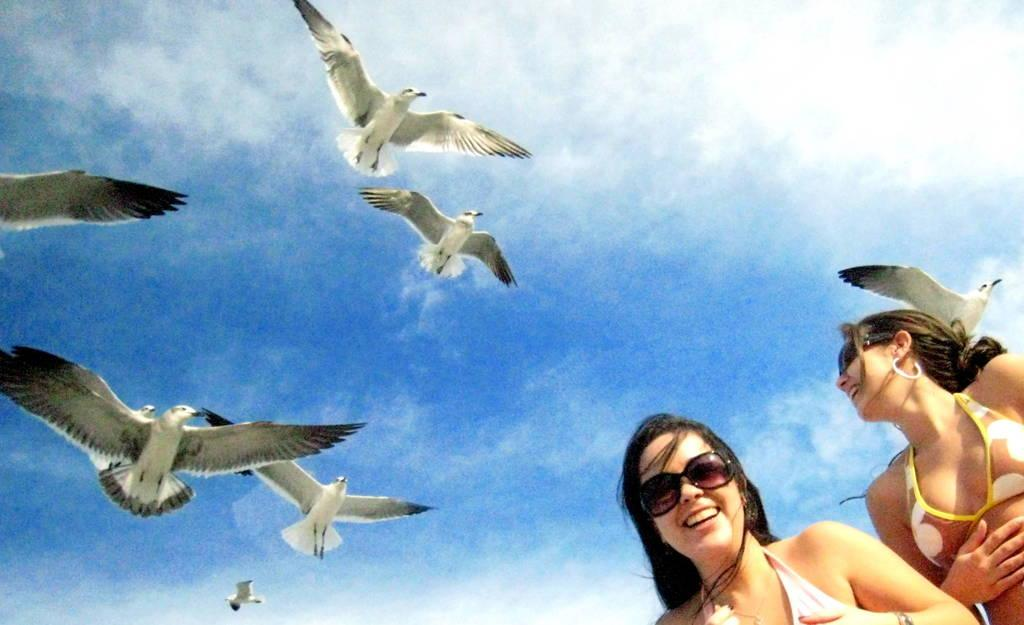How many women are present in the image? There are two women in the image. What are the women wearing on their faces? Both women are wearing spectacles. What can be seen in the sky in the image? There are birds flying in the air in the image. What type of horn can be seen on the plate in the image? There is no plate or horn present in the image. 